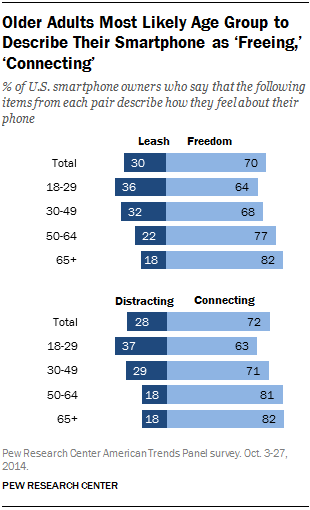Draw attention to some important aspects in this diagram. According to the results, 0.63 out of every 100 adults aged 18-29 perceive their phone as a tool for staying connected. The average among all ages that describe their phone as "Leash" is 0.276. 